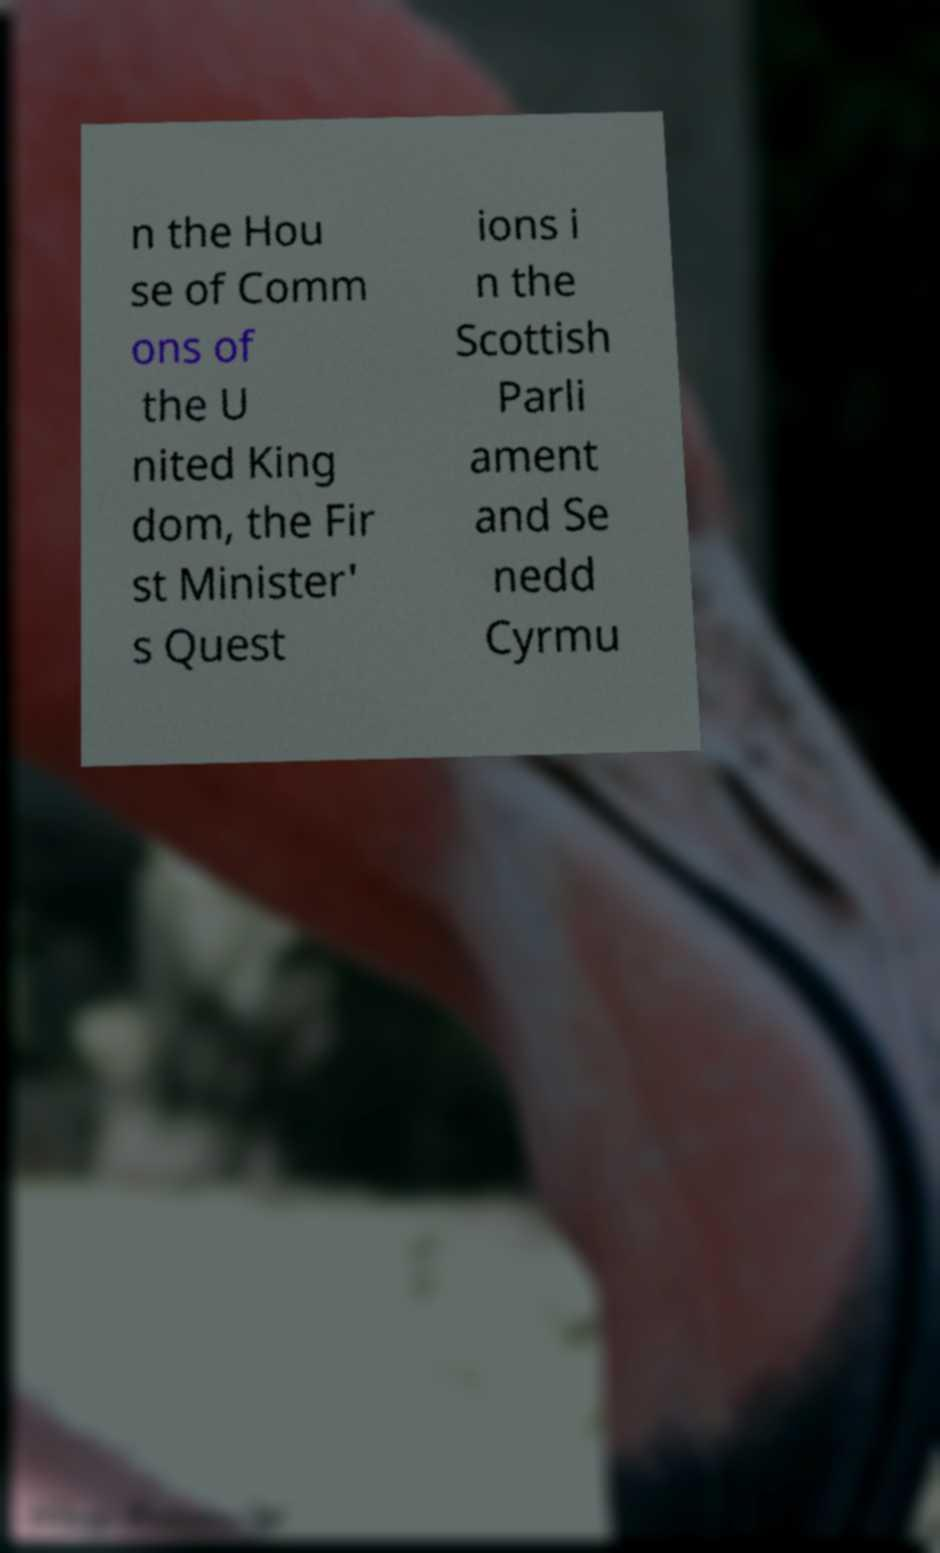There's text embedded in this image that I need extracted. Can you transcribe it verbatim? n the Hou se of Comm ons of the U nited King dom, the Fir st Minister' s Quest ions i n the Scottish Parli ament and Se nedd Cyrmu 